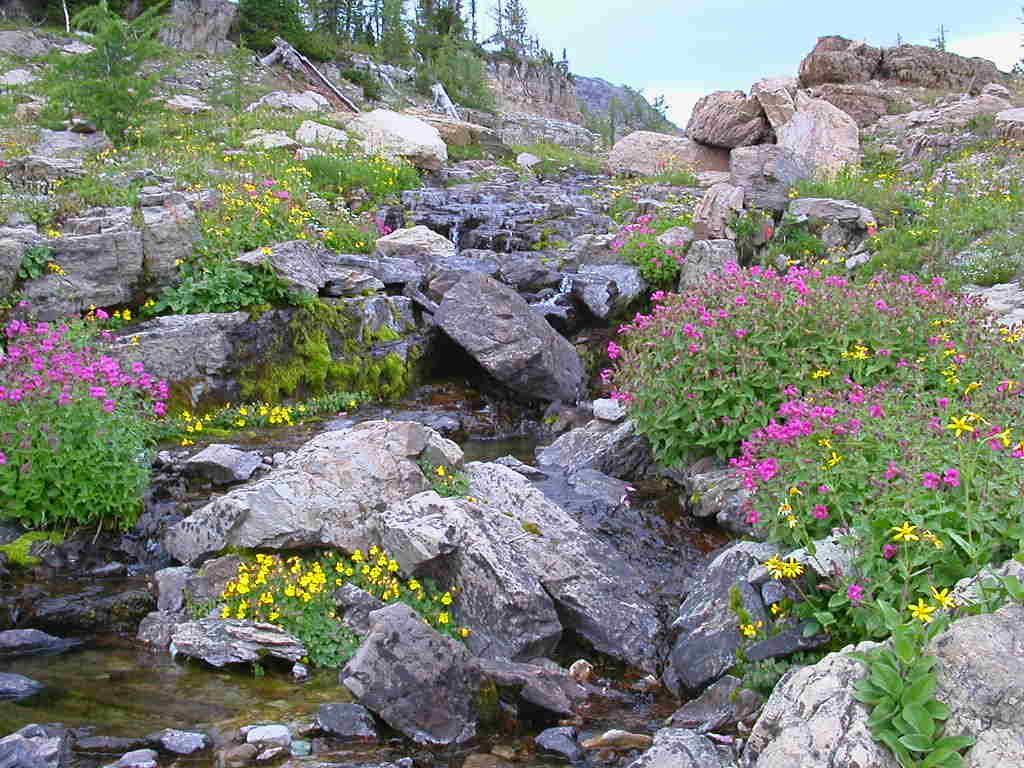Describe this image in one or two sentences. In this image at the bottom there are some plants, flowers, rocks and some water and in the background there are some rocks. At the top of the image there is sky. 